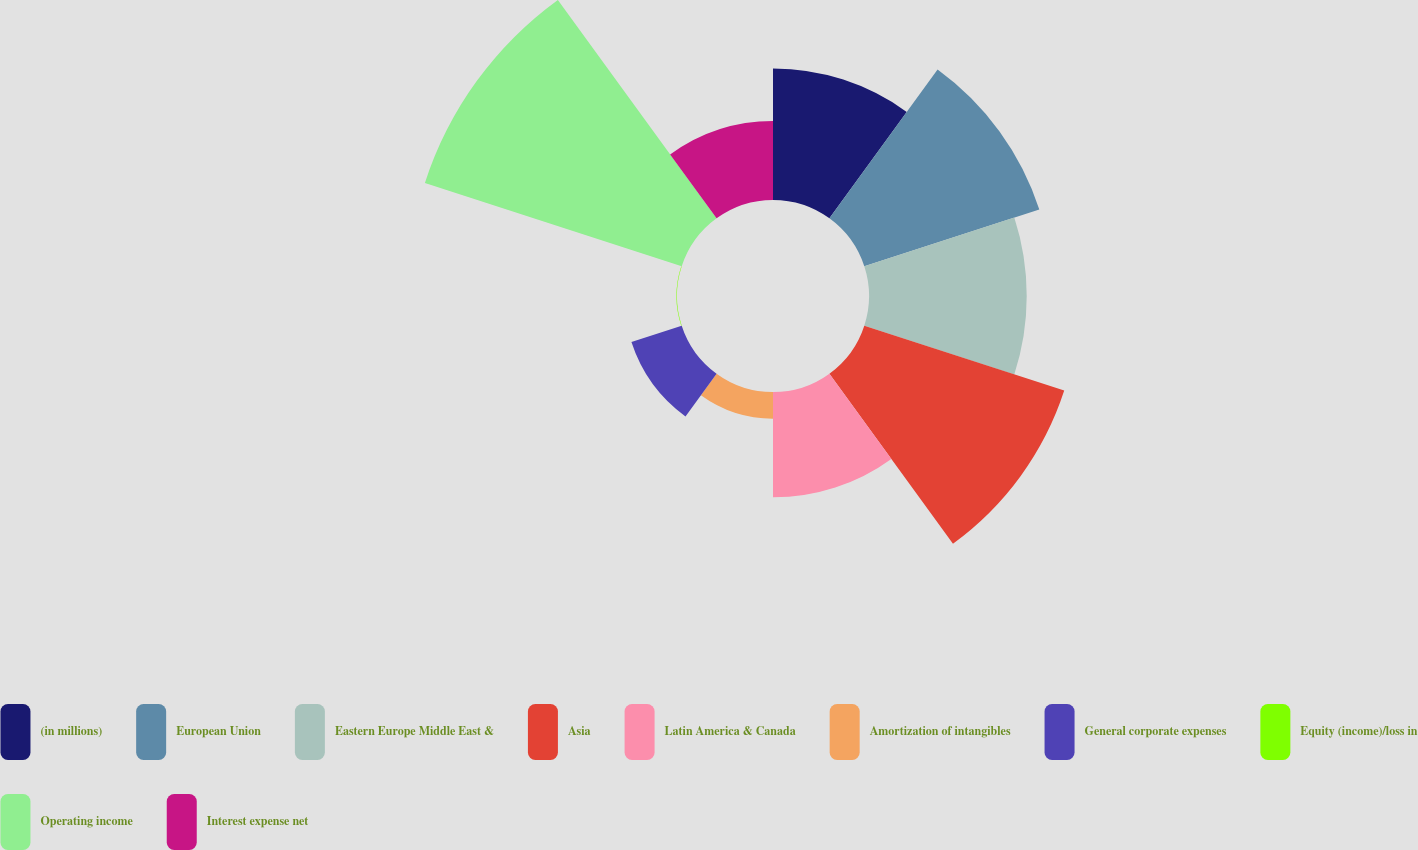Convert chart to OTSL. <chart><loc_0><loc_0><loc_500><loc_500><pie_chart><fcel>(in millions)<fcel>European Union<fcel>Eastern Europe Middle East &<fcel>Asia<fcel>Latin America & Canada<fcel>Amortization of intangibles<fcel>General corporate expenses<fcel>Equity (income)/loss in<fcel>Operating income<fcel>Interest expense net<nl><fcel>10.8%<fcel>15.11%<fcel>12.95%<fcel>17.26%<fcel>8.65%<fcel>2.19%<fcel>4.34%<fcel>0.04%<fcel>22.17%<fcel>6.49%<nl></chart> 